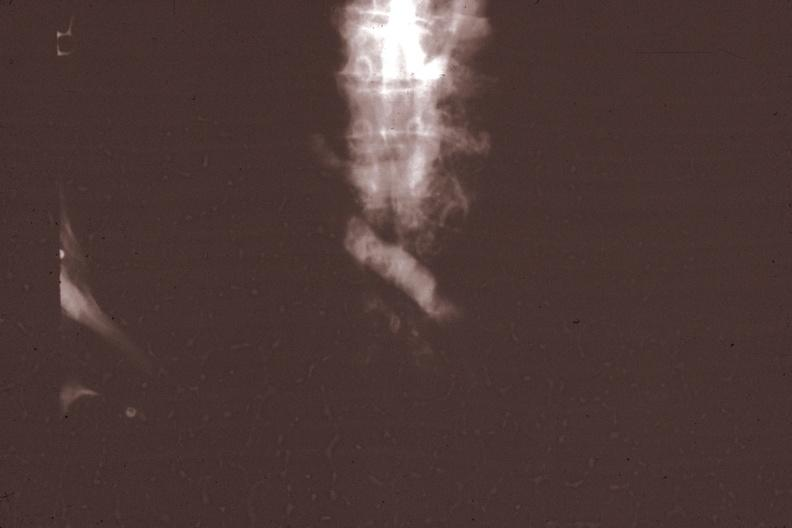does gross photo of tumor in this file correspond?
Answer the question using a single word or phrase. Yes 